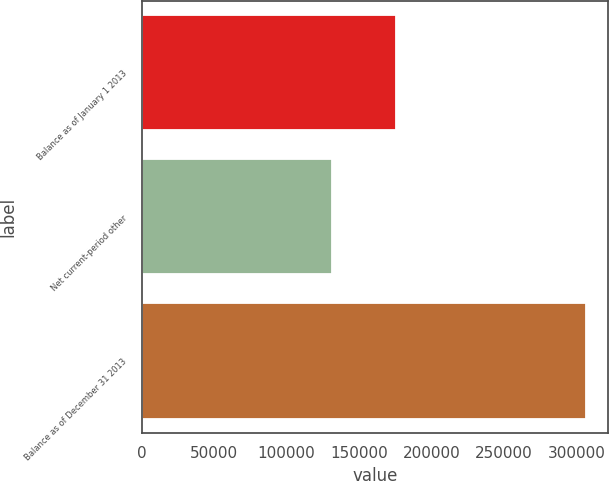<chart> <loc_0><loc_0><loc_500><loc_500><bar_chart><fcel>Balance as of January 1 2013<fcel>Net current-period other<fcel>Balance as of December 31 2013<nl><fcel>175162<fcel>131160<fcel>306322<nl></chart> 